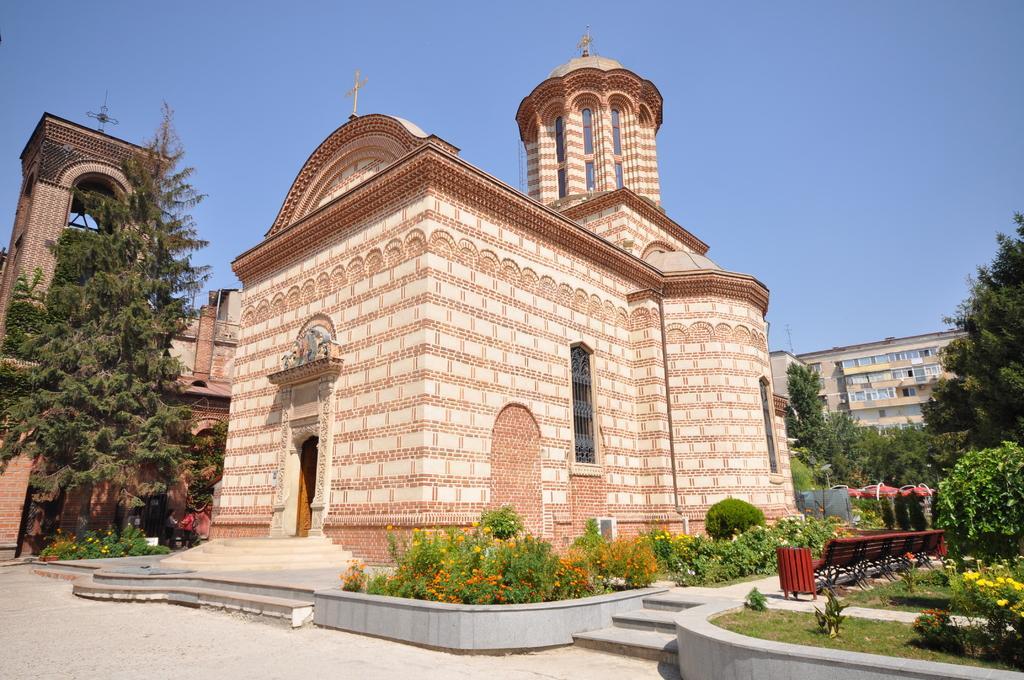Could you give a brief overview of what you see in this image? In this picture there is a monument in the center of the image and there are flower plants in the image, there are trees and buildings in the image. 